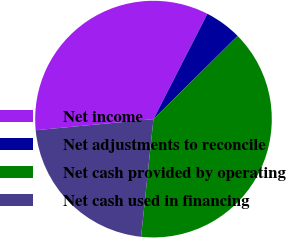Convert chart to OTSL. <chart><loc_0><loc_0><loc_500><loc_500><pie_chart><fcel>Net income<fcel>Net adjustments to reconcile<fcel>Net cash provided by operating<fcel>Net cash used in financing<nl><fcel>34.02%<fcel>5.06%<fcel>39.08%<fcel>21.83%<nl></chart> 